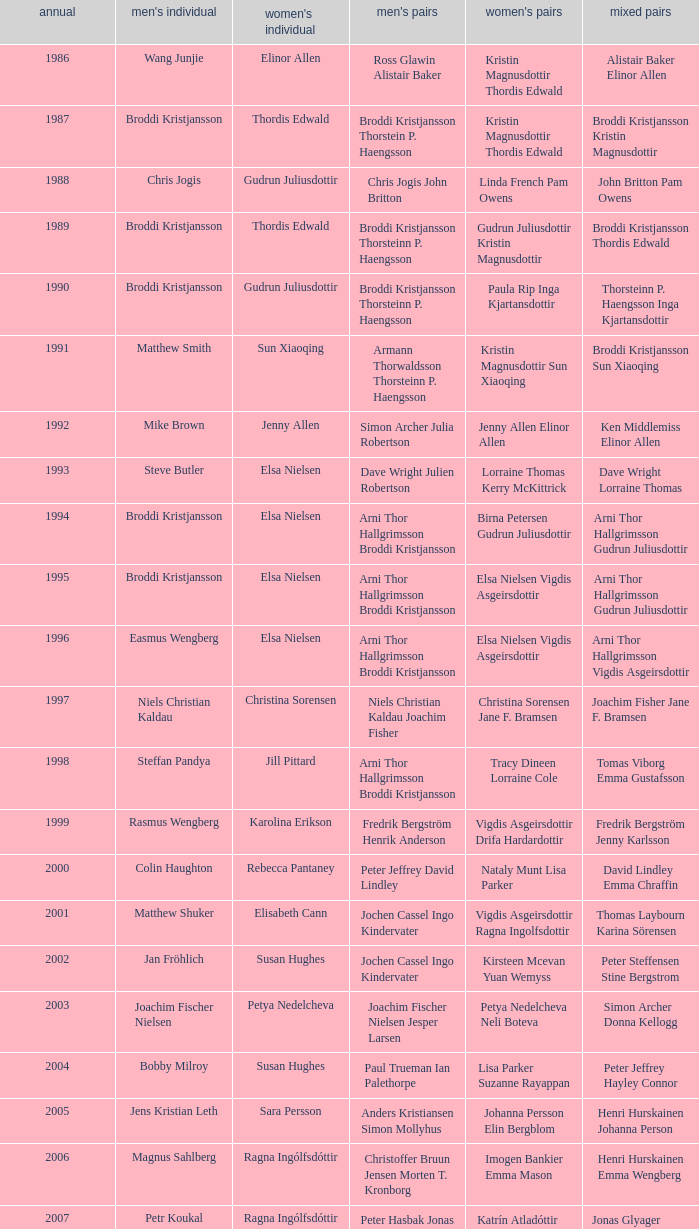Which mixed doubles happened later than 2011? Chou Tien-chen Chiang Mei-hui. 